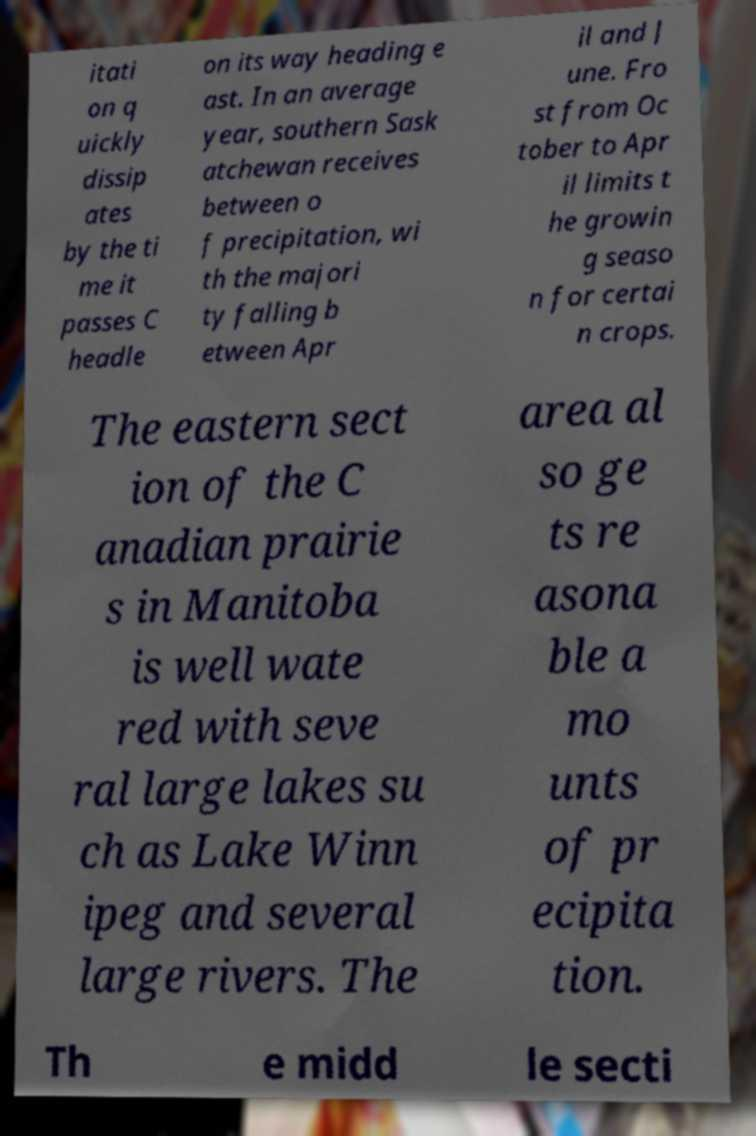There's text embedded in this image that I need extracted. Can you transcribe it verbatim? itati on q uickly dissip ates by the ti me it passes C headle on its way heading e ast. In an average year, southern Sask atchewan receives between o f precipitation, wi th the majori ty falling b etween Apr il and J une. Fro st from Oc tober to Apr il limits t he growin g seaso n for certai n crops. The eastern sect ion of the C anadian prairie s in Manitoba is well wate red with seve ral large lakes su ch as Lake Winn ipeg and several large rivers. The area al so ge ts re asona ble a mo unts of pr ecipita tion. Th e midd le secti 